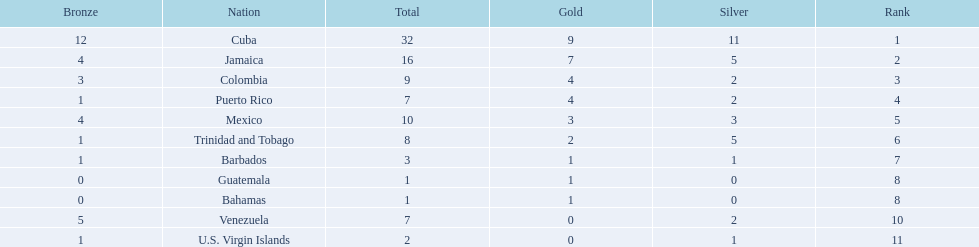What is the difference in medals between cuba and mexico? 22. 